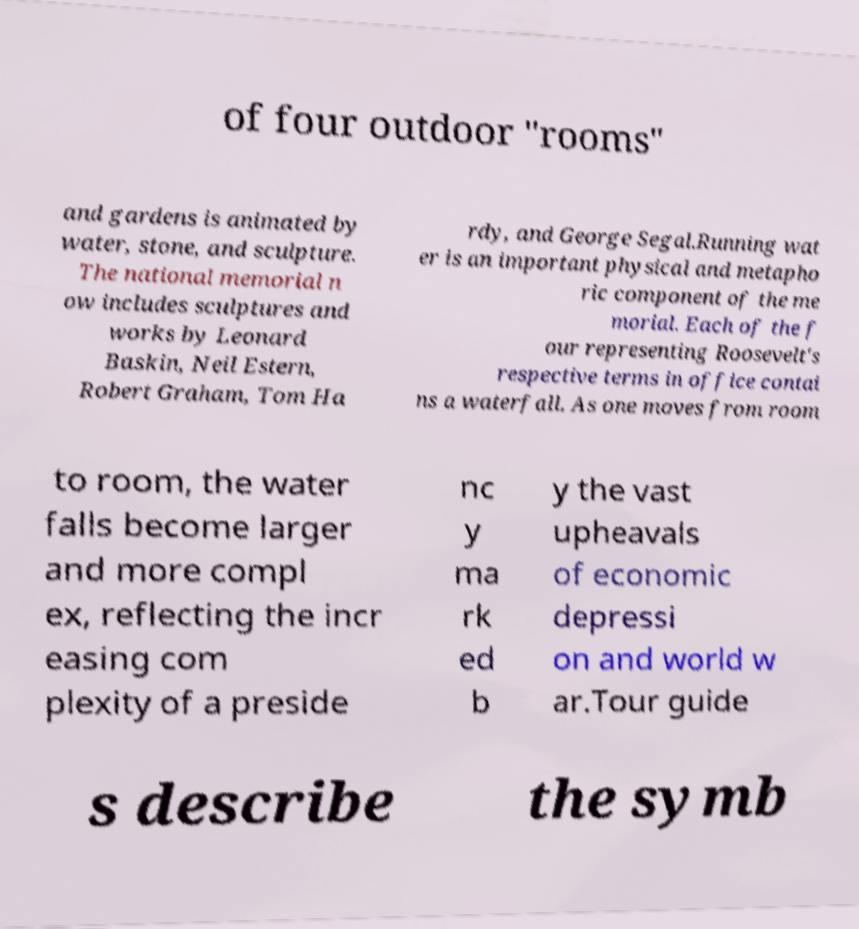Please identify and transcribe the text found in this image. of four outdoor "rooms" and gardens is animated by water, stone, and sculpture. The national memorial n ow includes sculptures and works by Leonard Baskin, Neil Estern, Robert Graham, Tom Ha rdy, and George Segal.Running wat er is an important physical and metapho ric component of the me morial. Each of the f our representing Roosevelt's respective terms in office contai ns a waterfall. As one moves from room to room, the water falls become larger and more compl ex, reflecting the incr easing com plexity of a preside nc y ma rk ed b y the vast upheavals of economic depressi on and world w ar.Tour guide s describe the symb 